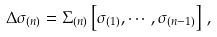Convert formula to latex. <formula><loc_0><loc_0><loc_500><loc_500>\Delta \sigma _ { ( n ) } = \Sigma _ { ( n ) } \left [ \sigma _ { ( 1 ) } , \cdots , \sigma _ { ( n - 1 ) } \right ] \, ,</formula> 